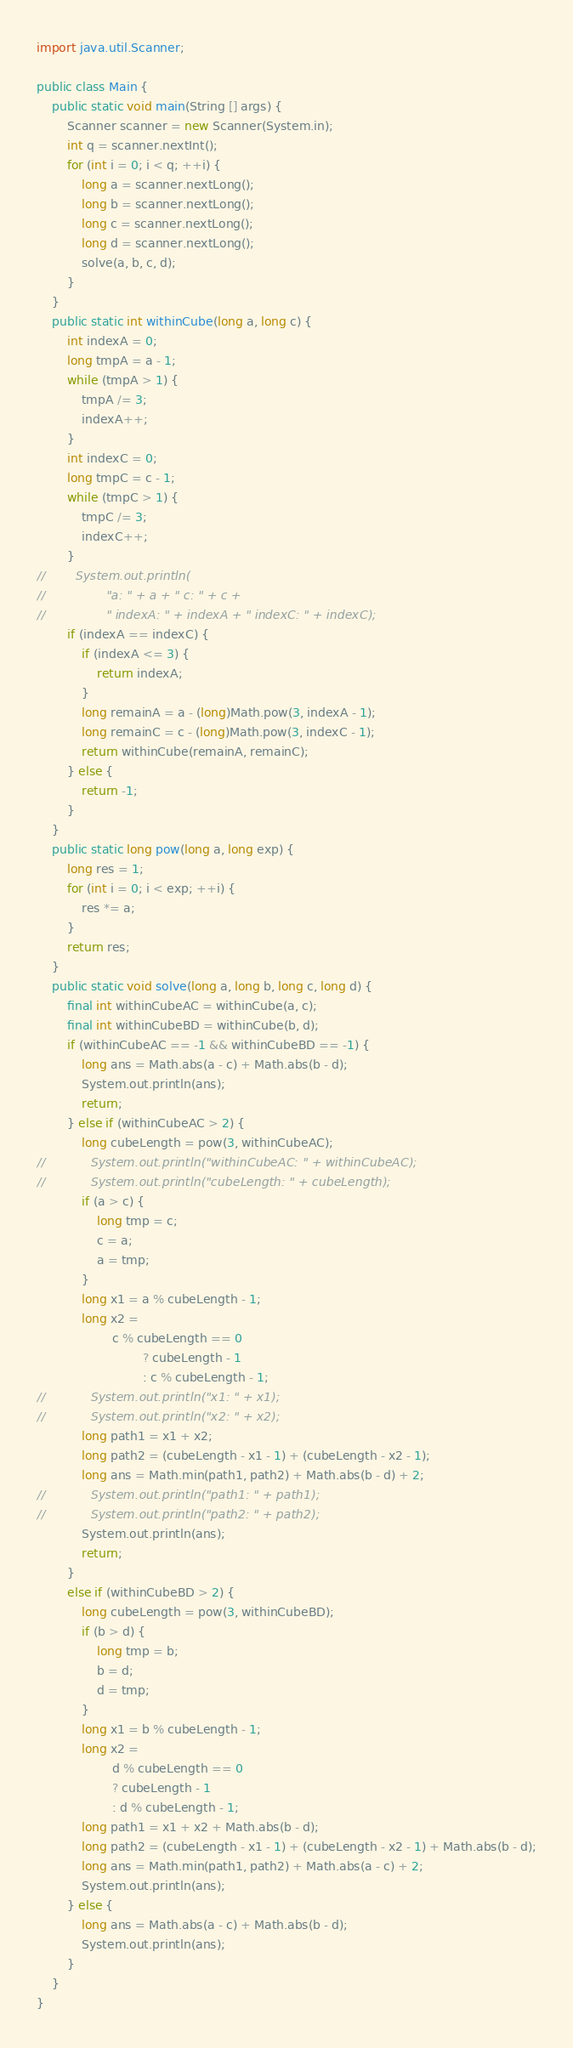Convert code to text. <code><loc_0><loc_0><loc_500><loc_500><_Java_>
import java.util.Scanner;

public class Main {
    public static void main(String [] args) {
        Scanner scanner = new Scanner(System.in);
        int q = scanner.nextInt();
        for (int i = 0; i < q; ++i) {
            long a = scanner.nextLong();
            long b = scanner.nextLong();
            long c = scanner.nextLong();
            long d = scanner.nextLong();
            solve(a, b, c, d);
        }
    }
    public static int withinCube(long a, long c) {
        int indexA = 0;
        long tmpA = a - 1;
        while (tmpA > 1) {
            tmpA /= 3;
            indexA++;
        }
        int indexC = 0;
        long tmpC = c - 1;
        while (tmpC > 1) {
            tmpC /= 3;
            indexC++;
        }
//        System.out.println(
//                "a: " + a + " c: " + c +
//                " indexA: " + indexA + " indexC: " + indexC);
        if (indexA == indexC) {
            if (indexA <= 3) {
                return indexA;
            }
            long remainA = a - (long)Math.pow(3, indexA - 1);
            long remainC = c - (long)Math.pow(3, indexC - 1);
            return withinCube(remainA, remainC);
        } else {
            return -1;
        }
    }
    public static long pow(long a, long exp) {
        long res = 1;
        for (int i = 0; i < exp; ++i) {
            res *= a;
        }
        return res;
    }
    public static void solve(long a, long b, long c, long d) {
        final int withinCubeAC = withinCube(a, c);
        final int withinCubeBD = withinCube(b, d);
        if (withinCubeAC == -1 && withinCubeBD == -1) {
            long ans = Math.abs(a - c) + Math.abs(b - d);
            System.out.println(ans);
            return;
        } else if (withinCubeAC > 2) {
            long cubeLength = pow(3, withinCubeAC);
//            System.out.println("withinCubeAC: " + withinCubeAC);
//            System.out.println("cubeLength: " + cubeLength);
            if (a > c) {
                long tmp = c;
                c = a;
                a = tmp;
            }
            long x1 = a % cubeLength - 1;
            long x2 =
                    c % cubeLength == 0
                            ? cubeLength - 1
                            : c % cubeLength - 1;
//            System.out.println("x1: " + x1);
//            System.out.println("x2: " + x2);
            long path1 = x1 + x2;
            long path2 = (cubeLength - x1 - 1) + (cubeLength - x2 - 1);
            long ans = Math.min(path1, path2) + Math.abs(b - d) + 2;
//            System.out.println("path1: " + path1);
//            System.out.println("path2: " + path2);
            System.out.println(ans);
            return;
        }
        else if (withinCubeBD > 2) {
            long cubeLength = pow(3, withinCubeBD);
            if (b > d) {
                long tmp = b;
                b = d;
                d = tmp;
            }
            long x1 = b % cubeLength - 1;
            long x2 =
                    d % cubeLength == 0
                    ? cubeLength - 1
                    : d % cubeLength - 1;
            long path1 = x1 + x2 + Math.abs(b - d);
            long path2 = (cubeLength - x1 - 1) + (cubeLength - x2 - 1) + Math.abs(b - d);
            long ans = Math.min(path1, path2) + Math.abs(a - c) + 2;
            System.out.println(ans);
        } else {
            long ans = Math.abs(a - c) + Math.abs(b - d);
            System.out.println(ans);
        }
    }
}
</code> 